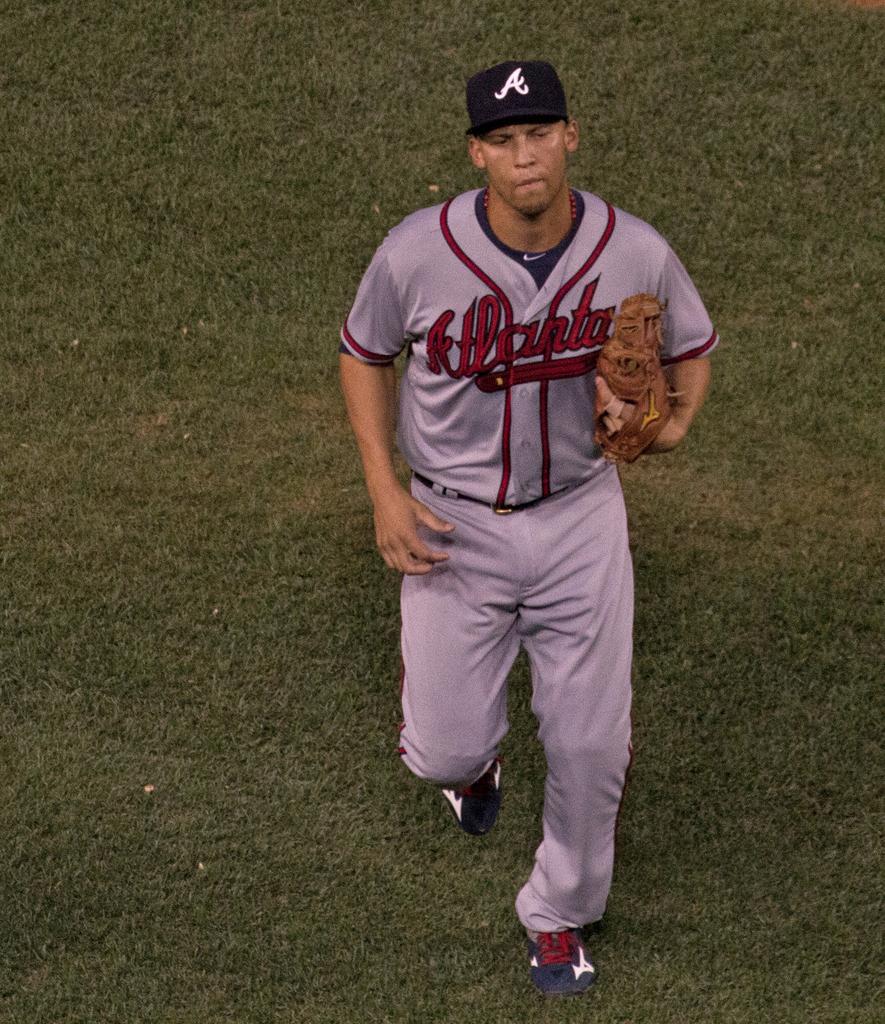What city name is on the front of the man's jersey?
Keep it short and to the point. Atlanta. What is on his hat?
Provide a succinct answer. A. 